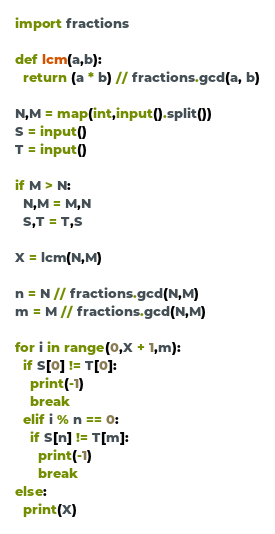Convert code to text. <code><loc_0><loc_0><loc_500><loc_500><_Python_>import fractions
  
def lcm(a,b):
  return (a * b) // fractions.gcd(a, b)

N,M = map(int,input().split())
S = input()
T = input()

if M > N:
  N,M = M,N
  S,T = T,S

X = lcm(N,M)

n = N // fractions.gcd(N,M)
m = M // fractions.gcd(N,M)

for i in range(0,X + 1,m):
  if S[0] != T[0]:
    print(-1)
    break
  elif i % n == 0:
    if S[n] != T[m]:
      print(-1)
      break
else:
  print(X)
</code> 